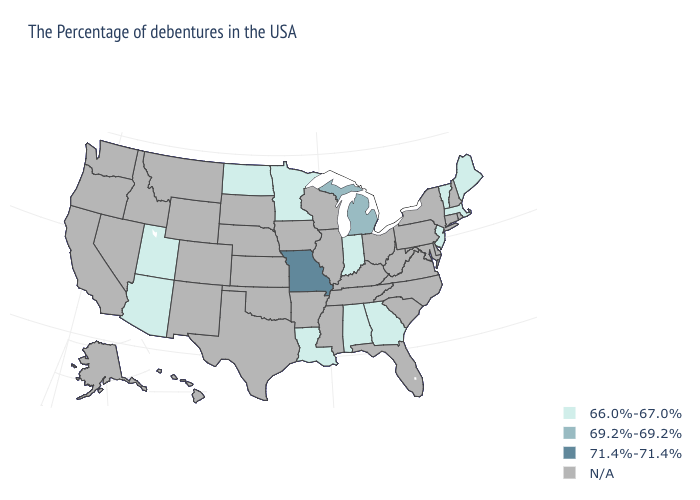What is the value of Colorado?
Keep it brief. N/A. Among the states that border Iowa , which have the highest value?
Keep it brief. Missouri. Does Michigan have the lowest value in the MidWest?
Short answer required. No. Name the states that have a value in the range 71.4%-71.4%?
Quick response, please. Missouri. Which states hav the highest value in the MidWest?
Keep it brief. Missouri. Does Arizona have the lowest value in the USA?
Be succinct. Yes. Name the states that have a value in the range 71.4%-71.4%?
Give a very brief answer. Missouri. Name the states that have a value in the range 71.4%-71.4%?
Answer briefly. Missouri. What is the value of Arizona?
Quick response, please. 66.0%-67.0%. Name the states that have a value in the range 69.2%-69.2%?
Keep it brief. Michigan. What is the highest value in the South ?
Answer briefly. 66.0%-67.0%. Does Louisiana have the lowest value in the USA?
Keep it brief. Yes. Is the legend a continuous bar?
Quick response, please. No. 